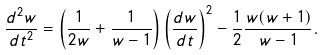<formula> <loc_0><loc_0><loc_500><loc_500>\frac { d ^ { 2 } w } { d t ^ { 2 } } = \left ( \frac { 1 } { 2 w } + \frac { 1 } { w - 1 } \right ) \left ( \frac { d w } { d t } \right ) ^ { 2 } - \frac { 1 } { 2 } \frac { w ( w + 1 ) } { w - 1 } .</formula> 